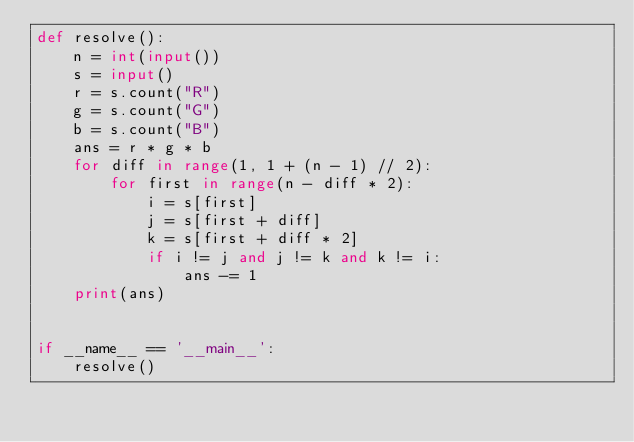Convert code to text. <code><loc_0><loc_0><loc_500><loc_500><_Python_>def resolve():
    n = int(input())
    s = input()
    r = s.count("R")
    g = s.count("G")
    b = s.count("B")
    ans = r * g * b
    for diff in range(1, 1 + (n - 1) // 2):
        for first in range(n - diff * 2):
            i = s[first]
            j = s[first + diff]
            k = s[first + diff * 2]
            if i != j and j != k and k != i:
                ans -= 1
    print(ans)


if __name__ == '__main__':
    resolve()
</code> 